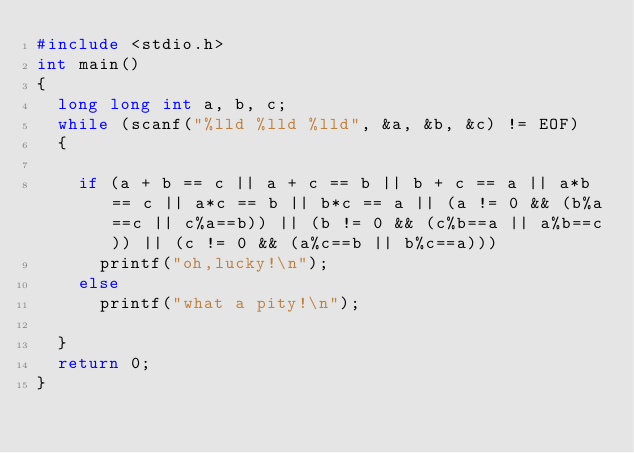<code> <loc_0><loc_0><loc_500><loc_500><_C_>#include <stdio.h>
int main()
{
	long long int a, b, c;
	while (scanf("%lld %lld %lld", &a, &b, &c) != EOF)
	{

		if (a + b == c || a + c == b || b + c == a || a*b == c || a*c == b || b*c == a || (a != 0 && (b%a==c || c%a==b)) || (b != 0 && (c%b==a || a%b==c)) || (c != 0 && (a%c==b || b%c==a)))
			printf("oh,lucky!\n");
		else
			printf("what a pity!\n");

	}
	return 0;
}
</code> 